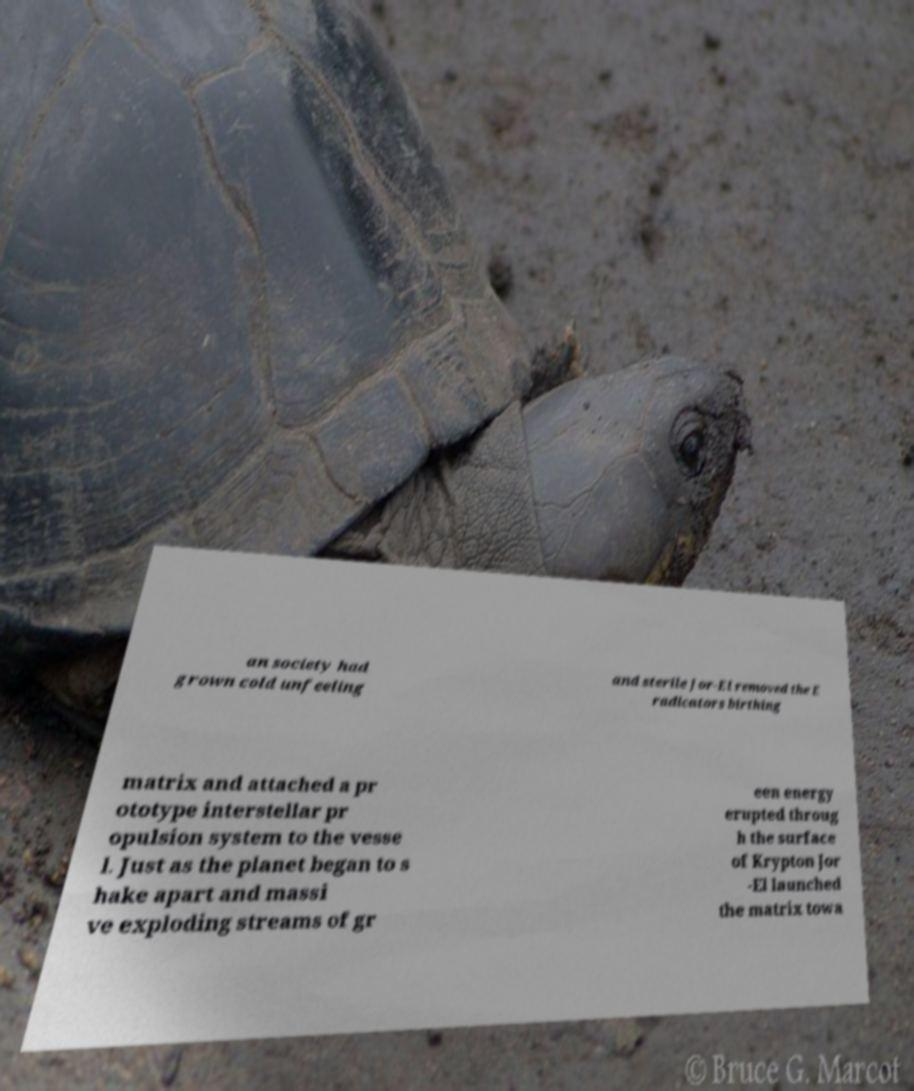I need the written content from this picture converted into text. Can you do that? an society had grown cold unfeeling and sterile Jor-El removed the E radicators birthing matrix and attached a pr ototype interstellar pr opulsion system to the vesse l. Just as the planet began to s hake apart and massi ve exploding streams of gr een energy erupted throug h the surface of Krypton Jor -El launched the matrix towa 